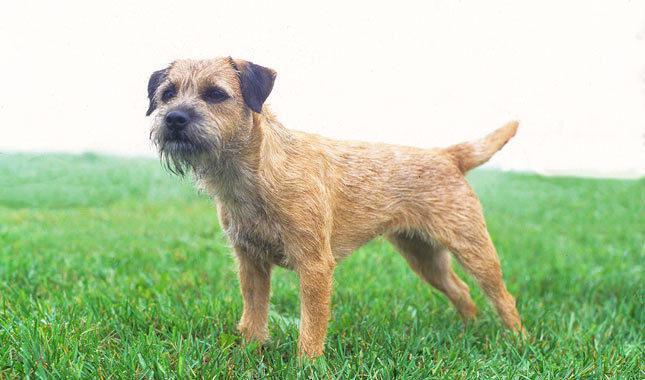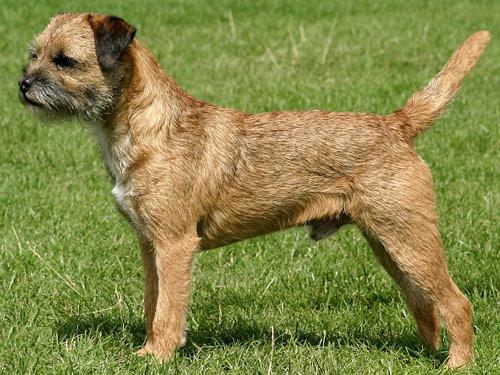The first image is the image on the left, the second image is the image on the right. Evaluate the accuracy of this statement regarding the images: "The dogs in the images are standing with bodies turned in opposite directions.". Is it true? Answer yes or no. No. 